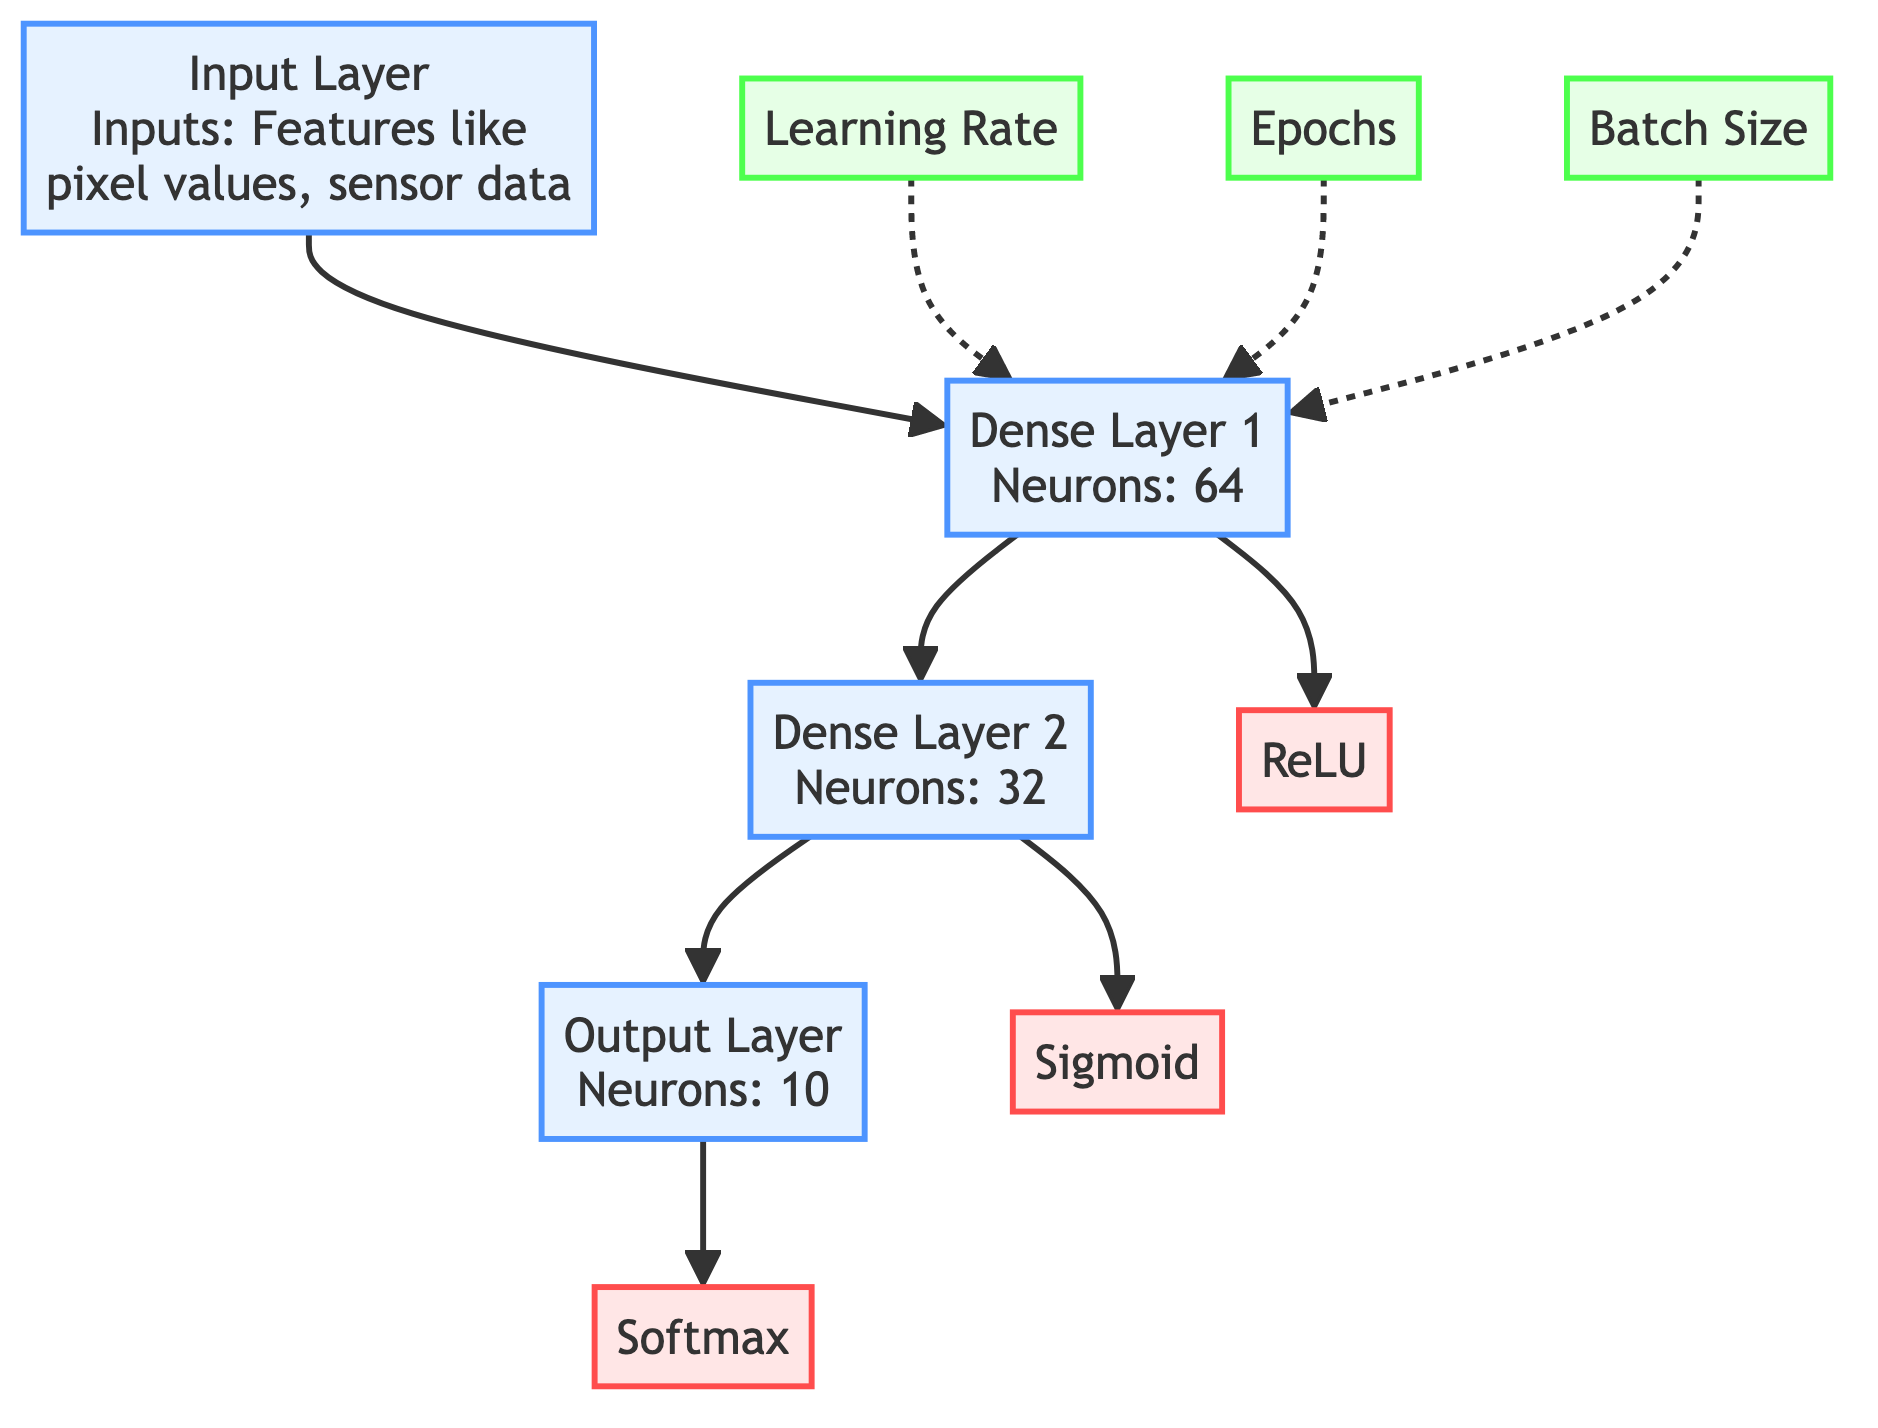What are the neurons in Dense Layer 1? The diagram specifically lists the number of neurons in Dense Layer 1 as 64.
Answer: 64 What is the activation function used in Dense Layer 2? According to the diagram, Dense Layer 2 utilizes the Sigmoid activation function.
Answer: Sigmoid Which layer comes after the first dense layer? Following the flow in the diagram, the layer that comes after Dense Layer 1 is Dense Layer 2.
Answer: Dense Layer 2 How many layers are there in total? The diagram clearly indicates there are four layers: Input Layer, Dense Layer 1, Dense Layer 2, and Output Layer.
Answer: 4 What is the last activation function in the diagram? The diagram shows that the last activation function is Softmax, which is associated with the Output Layer.
Answer: Softmax What hyperparameter connects to the dense layers? The diagram indicates that the Learning Rate, Epochs, and Batch Size hyperparameters relate to Dense Layer 1.
Answer: Learning Rate, Epochs, Batch Size Which activation function is connected to Dense Layer 1? The diagram identifies ReLU as the activation function connected to Dense Layer 1.
Answer: ReLU What type of layer is the output layer? The Output Layer is categorized as a layer, specifically with neurons numbered at 10.
Answer: Layer Which layer does the output layer connect to? In the flow of the diagram, the Output Layer directly connects to the Softmax activation function.
Answer: Softmax 